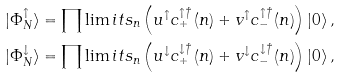<formula> <loc_0><loc_0><loc_500><loc_500>| \Phi _ { N } ^ { \uparrow } \rangle & = \prod \lim i t s _ { n } \left ( u ^ { \uparrow } c _ { + } ^ { \uparrow \dagger } \left ( n \right ) + v ^ { \uparrow } c _ { - } ^ { \uparrow \dagger } \left ( n \right ) \right ) \left | 0 \right \rangle , \\ | \Phi _ { N } ^ { \downarrow } \rangle & = \prod \lim i t s _ { n } \left ( u ^ { \downarrow } c _ { + } ^ { \downarrow \dagger } \left ( n \right ) + v ^ { \downarrow } c _ { - } ^ { \downarrow \dagger } \left ( n \right ) \right ) \left | 0 \right \rangle ,</formula> 